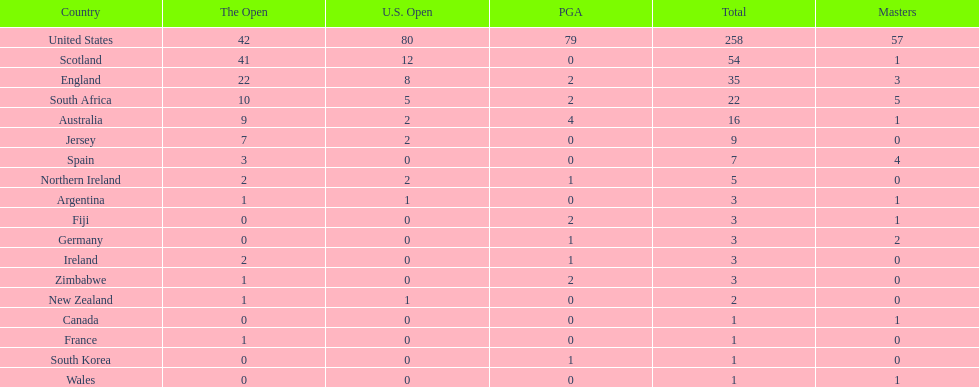Is the united stated or scotland better? United States. Would you mind parsing the complete table? {'header': ['Country', 'The Open', 'U.S. Open', 'PGA', 'Total', 'Masters'], 'rows': [['United States', '42', '80', '79', '258', '57'], ['Scotland', '41', '12', '0', '54', '1'], ['England', '22', '8', '2', '35', '3'], ['South Africa', '10', '5', '2', '22', '5'], ['Australia', '9', '2', '4', '16', '1'], ['Jersey', '7', '2', '0', '9', '0'], ['Spain', '3', '0', '0', '7', '4'], ['Northern Ireland', '2', '2', '1', '5', '0'], ['Argentina', '1', '1', '0', '3', '1'], ['Fiji', '0', '0', '2', '3', '1'], ['Germany', '0', '0', '1', '3', '2'], ['Ireland', '2', '0', '1', '3', '0'], ['Zimbabwe', '1', '0', '2', '3', '0'], ['New Zealand', '1', '1', '0', '2', '0'], ['Canada', '0', '0', '0', '1', '1'], ['France', '1', '0', '0', '1', '0'], ['South Korea', '0', '0', '1', '1', '0'], ['Wales', '0', '0', '0', '1', '1']]} 